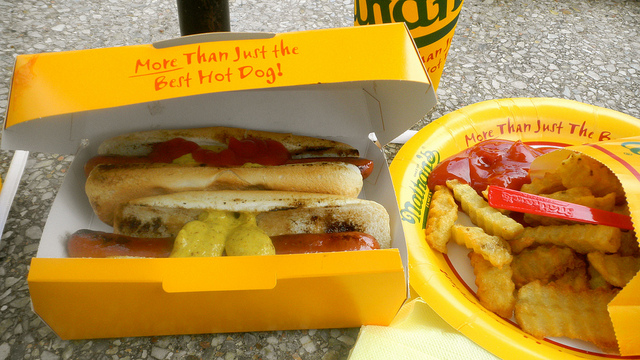Please extract the text content from this image. More Than Just the Best Hot Dog More Than just The of R 